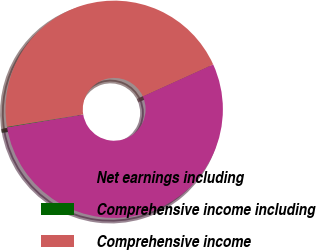Convert chart. <chart><loc_0><loc_0><loc_500><loc_500><pie_chart><fcel>Net earnings including<fcel>Comprehensive income including<fcel>Comprehensive income<nl><fcel>54.14%<fcel>0.08%<fcel>45.78%<nl></chart> 